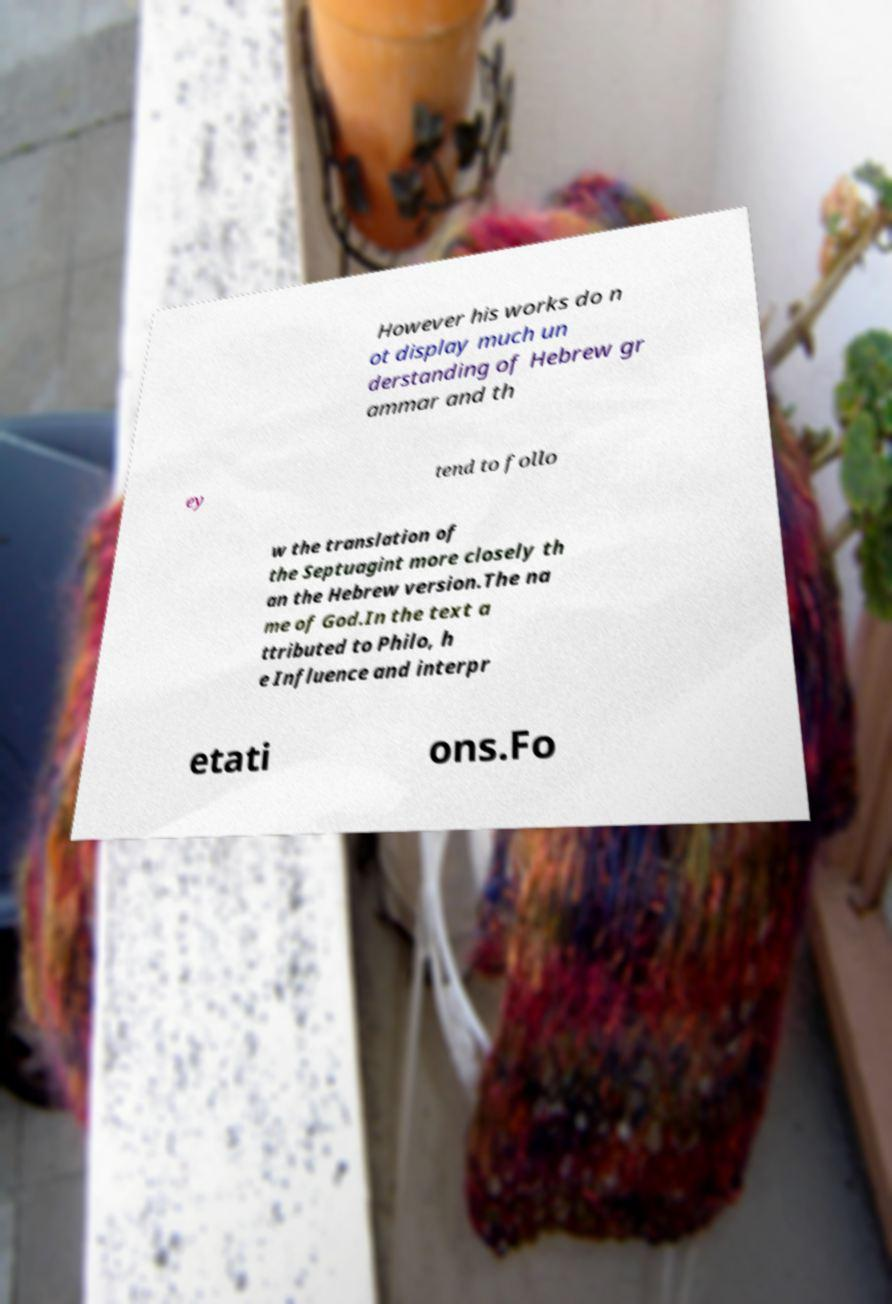What messages or text are displayed in this image? I need them in a readable, typed format. However his works do n ot display much un derstanding of Hebrew gr ammar and th ey tend to follo w the translation of the Septuagint more closely th an the Hebrew version.The na me of God.In the text a ttributed to Philo, h e Influence and interpr etati ons.Fo 